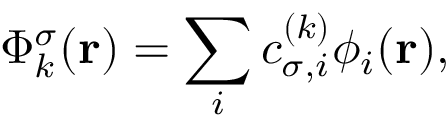<formula> <loc_0><loc_0><loc_500><loc_500>\Phi _ { k } ^ { \sigma } ( { r } ) = \sum _ { i } c _ { \sigma , i } ^ { ( k ) } \phi _ { i } ( { r } ) ,</formula> 